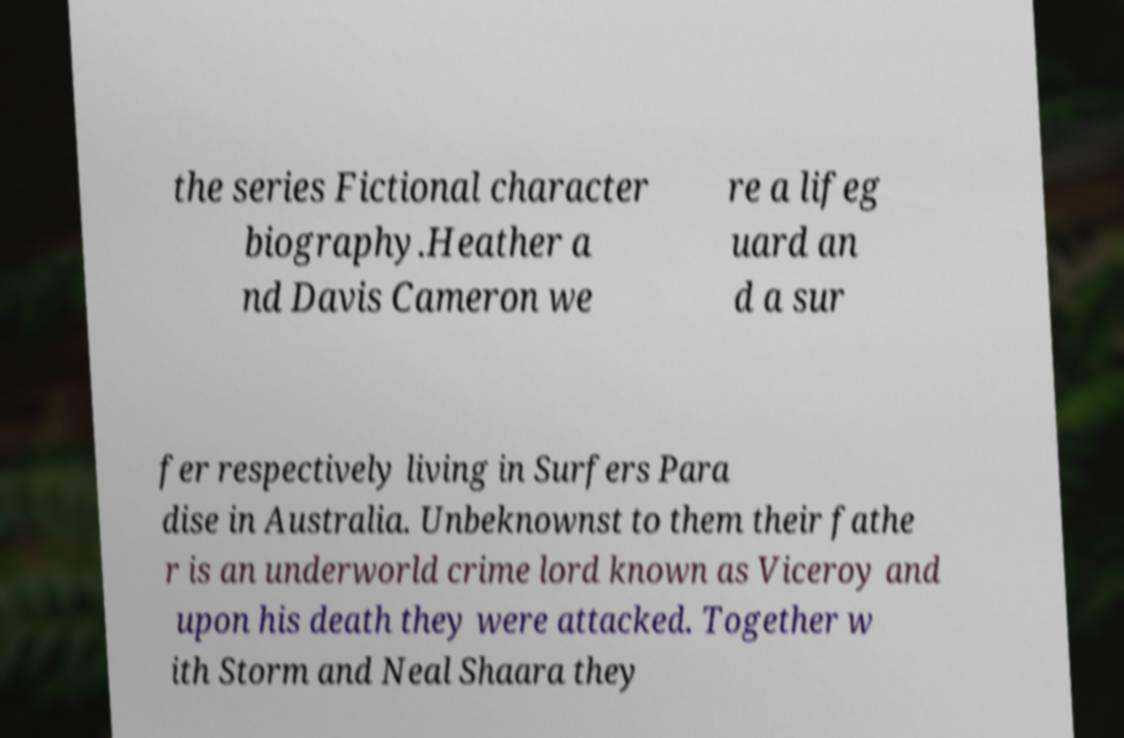What messages or text are displayed in this image? I need them in a readable, typed format. the series Fictional character biography.Heather a nd Davis Cameron we re a lifeg uard an d a sur fer respectively living in Surfers Para dise in Australia. Unbeknownst to them their fathe r is an underworld crime lord known as Viceroy and upon his death they were attacked. Together w ith Storm and Neal Shaara they 